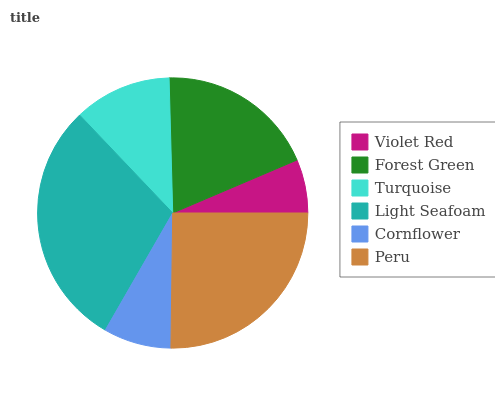Is Violet Red the minimum?
Answer yes or no. Yes. Is Light Seafoam the maximum?
Answer yes or no. Yes. Is Forest Green the minimum?
Answer yes or no. No. Is Forest Green the maximum?
Answer yes or no. No. Is Forest Green greater than Violet Red?
Answer yes or no. Yes. Is Violet Red less than Forest Green?
Answer yes or no. Yes. Is Violet Red greater than Forest Green?
Answer yes or no. No. Is Forest Green less than Violet Red?
Answer yes or no. No. Is Forest Green the high median?
Answer yes or no. Yes. Is Turquoise the low median?
Answer yes or no. Yes. Is Peru the high median?
Answer yes or no. No. Is Light Seafoam the low median?
Answer yes or no. No. 